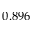<formula> <loc_0><loc_0><loc_500><loc_500>0 . 8 9 6</formula> 